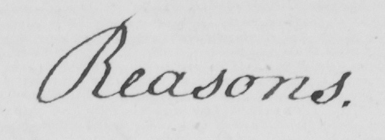Transcribe the text shown in this historical manuscript line. Reasons 